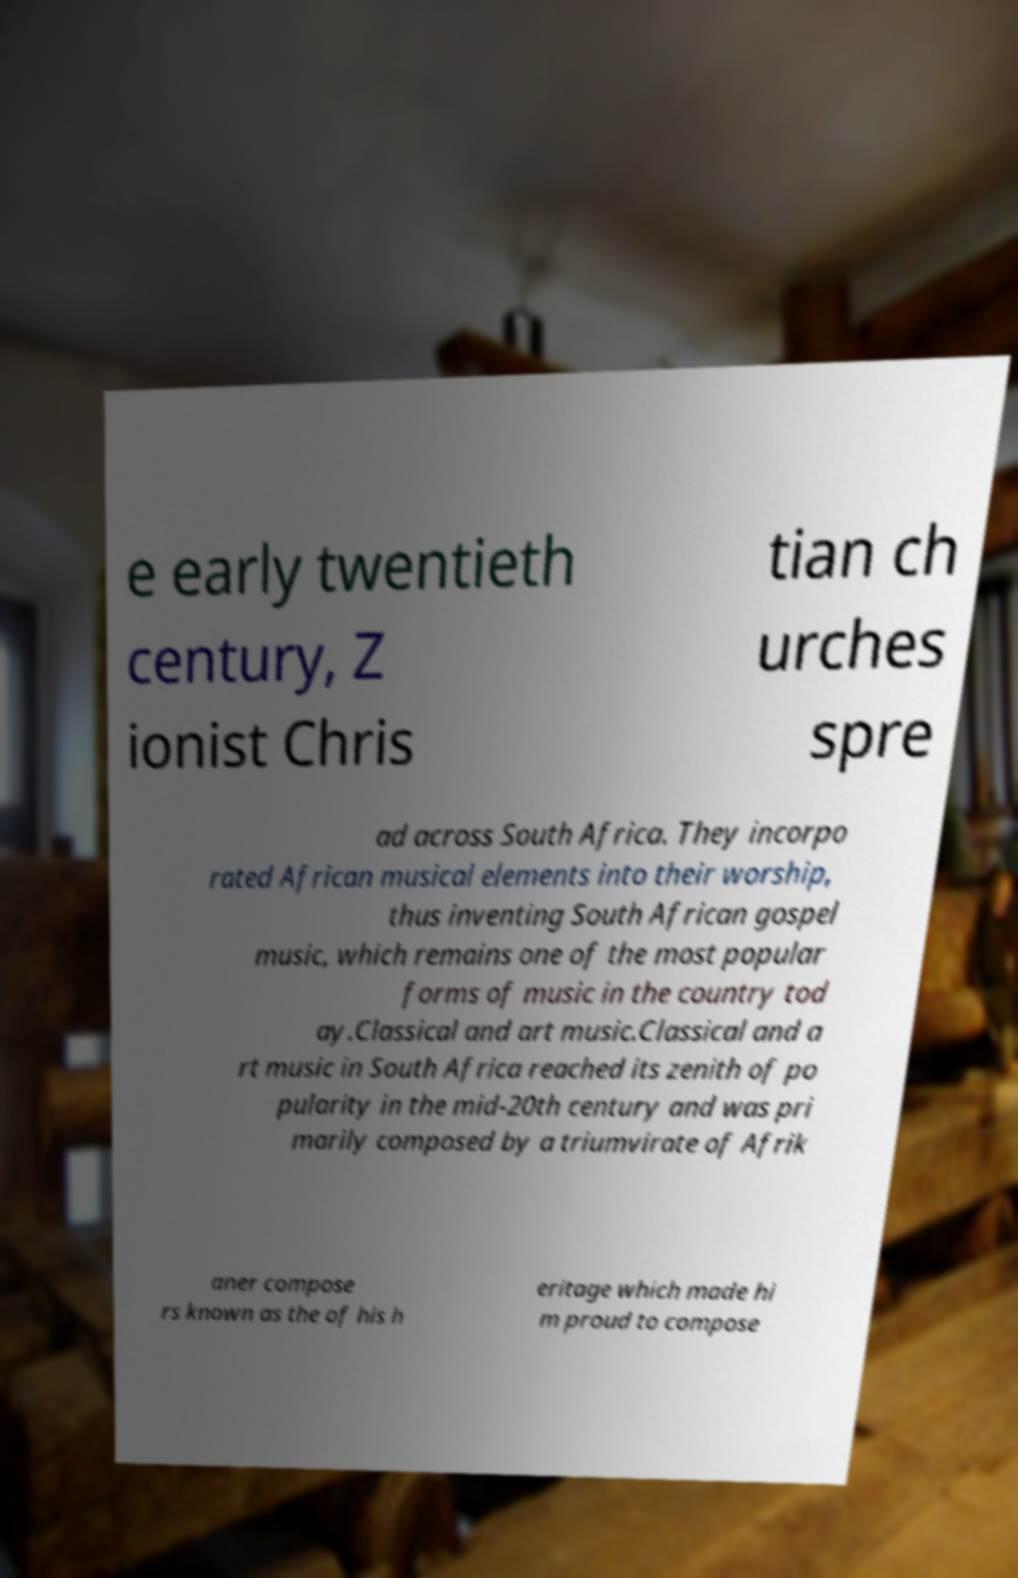Could you assist in decoding the text presented in this image and type it out clearly? e early twentieth century, Z ionist Chris tian ch urches spre ad across South Africa. They incorpo rated African musical elements into their worship, thus inventing South African gospel music, which remains one of the most popular forms of music in the country tod ay.Classical and art music.Classical and a rt music in South Africa reached its zenith of po pularity in the mid-20th century and was pri marily composed by a triumvirate of Afrik aner compose rs known as the of his h eritage which made hi m proud to compose 